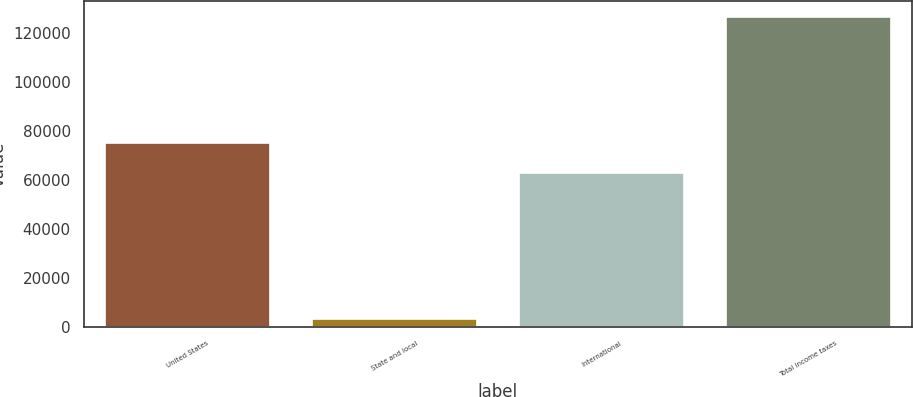Convert chart to OTSL. <chart><loc_0><loc_0><loc_500><loc_500><bar_chart><fcel>United States<fcel>State and local<fcel>International<fcel>Total income taxes<nl><fcel>75263.4<fcel>3134<fcel>62909<fcel>126678<nl></chart> 